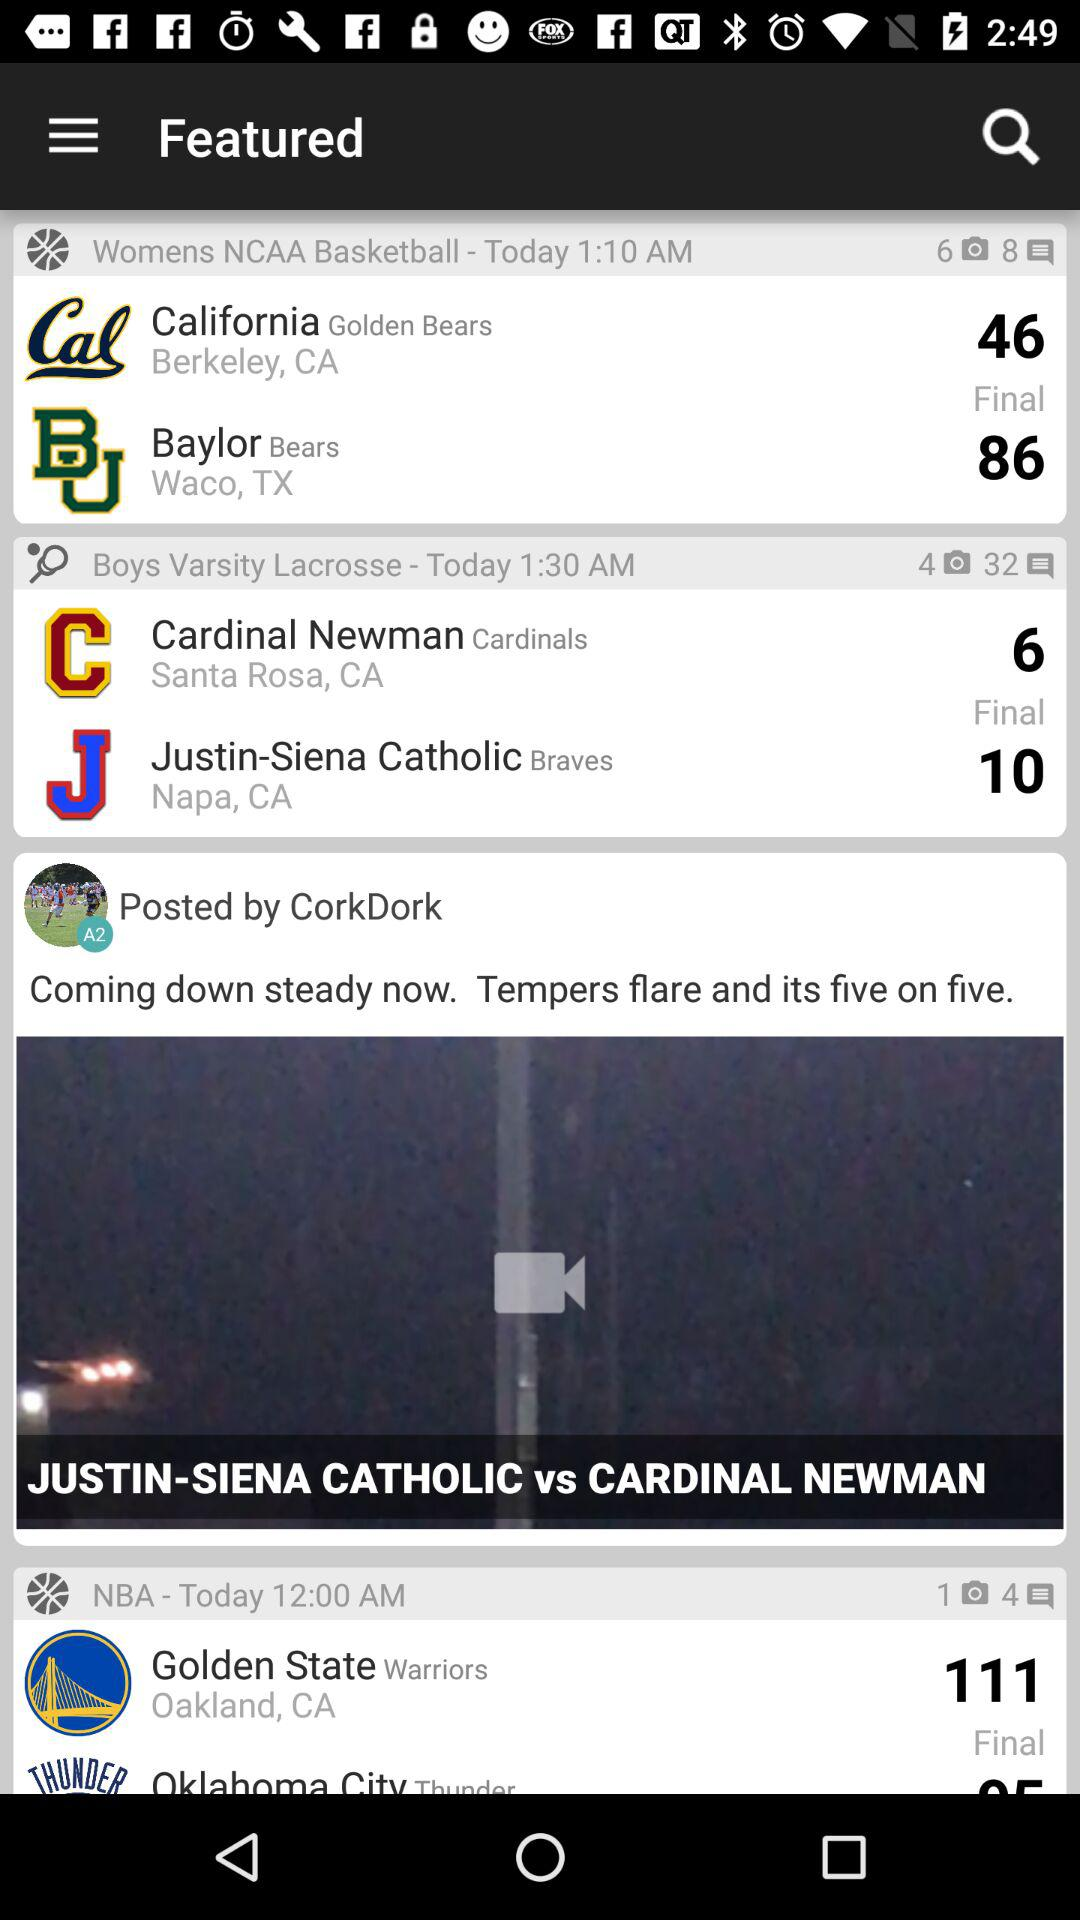What is the location of the golden state? The location of the golden state is Oakland, CA. 